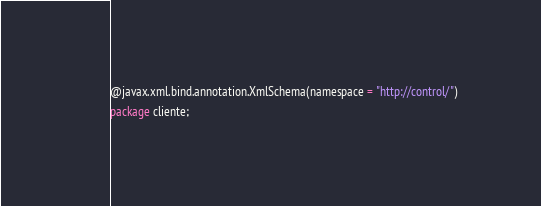<code> <loc_0><loc_0><loc_500><loc_500><_Java_>@javax.xml.bind.annotation.XmlSchema(namespace = "http://control/")
package cliente;
</code> 